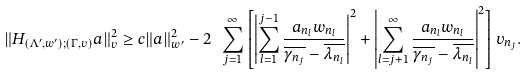<formula> <loc_0><loc_0><loc_500><loc_500>\| H _ { ( \Lambda ^ { \prime } , w ^ { \prime } ) ; ( \Gamma , v ) } a \| _ { v } ^ { 2 } \geq c \| a \| _ { w ^ { \prime } } ^ { 2 } - 2 \ \sum _ { j = 1 } ^ { \infty } \left [ \left | \sum _ { l = 1 } ^ { j - 1 } \frac { a _ { n _ { l } } w _ { n _ { l } } } { \overline { \gamma _ { n _ { j } } } - \overline { \lambda _ { n _ { l } } } } \right | ^ { 2 } + \left | \sum _ { l = j + 1 } ^ { \infty } \frac { a _ { n _ { l } } w _ { n _ { l } } } { \overline { \gamma _ { n _ { j } } } - \overline { \lambda _ { n _ { l } } } } \right | ^ { 2 } \right ] v _ { n _ { j } } .</formula> 